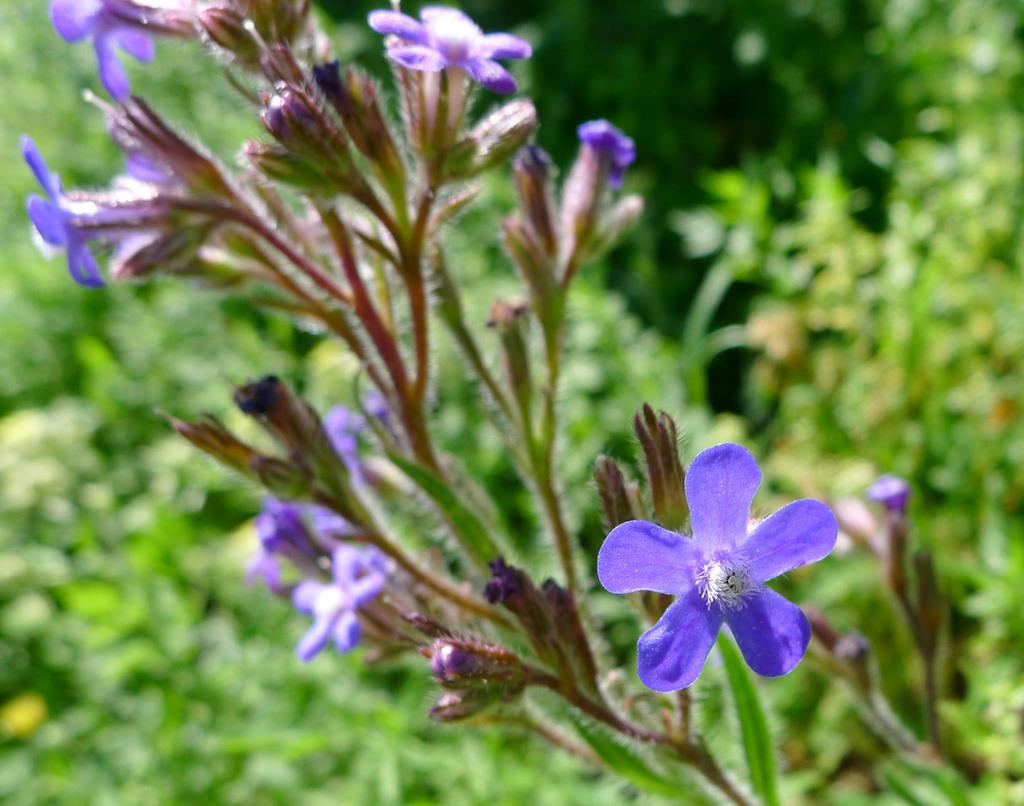What color are the flowers on the stem in the image? The flowers on the stem are violet in color. What can be seen on the stem besides the flowers? There are buds and leaves on the stem. How would you describe the background of the image? The background of the image is blurred. What type of toothpaste is used to clean the flowers in the image? There is no toothpaste present in the image, and flowers do not require cleaning with toothpaste. 